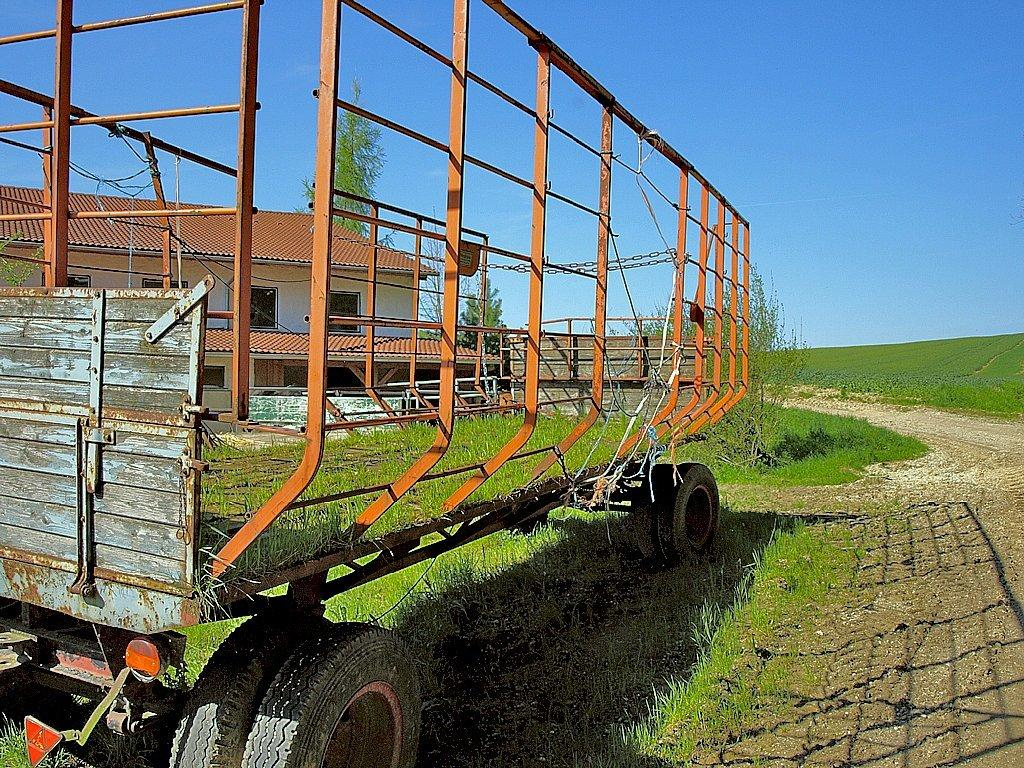What type of terrain is visible in the image? There is an open grass ground in the image. What object is located in the front of the image? There is a trolley in the front of the image. What can be seen in the background of the image? There are trees, a building, and the sky visible in the background of the image. How many snakes are slithering on the seat in the image? There are no snakes present in the image, and there is no seat mentioned in the facts provided. 